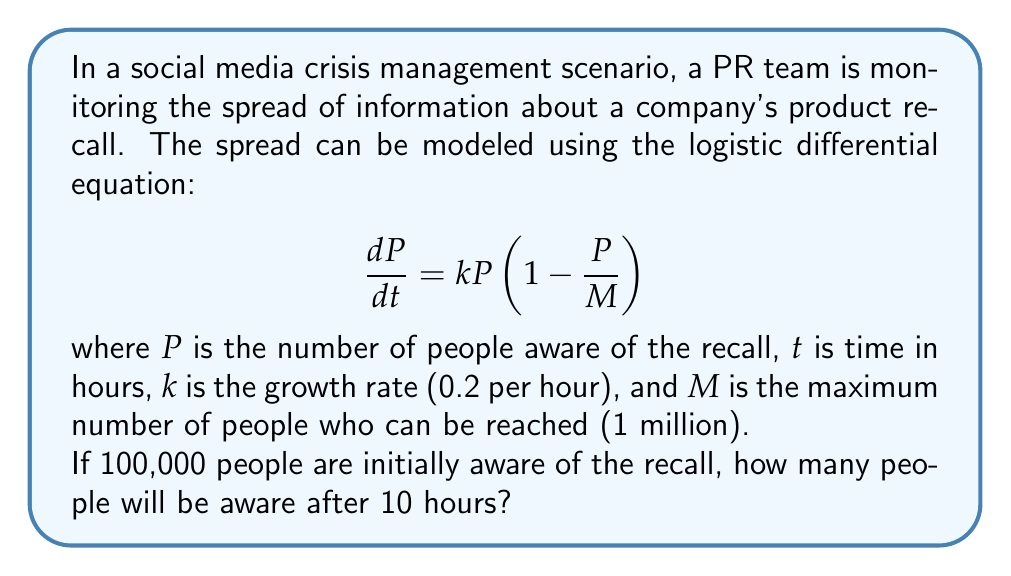Solve this math problem. To solve this problem, we need to use the solution to the logistic differential equation:

$$P(t) = \frac{M}{1 + (\frac{M}{P_0} - 1)e^{-kt}}$$

Where:
- $M = 1,000,000$ (maximum reach)
- $k = 0.2$ (growth rate per hour)
- $P_0 = 100,000$ (initial awareness)
- $t = 10$ (hours)

Let's substitute these values into the equation:

$$P(10) = \frac{1,000,000}{1 + (\frac{1,000,000}{100,000} - 1)e^{-0.2 \cdot 10}}$$

$$= \frac{1,000,000}{1 + (10 - 1)e^{-2}}$$

$$= \frac{1,000,000}{1 + 9e^{-2}}$$

Now, let's calculate:

1. $e^{-2} \approx 0.1353$
2. $9 \cdot 0.1353 = 1.2177$
3. $1 + 1.2177 = 2.2177$

Therefore:

$$P(10) = \frac{1,000,000}{2.2177} \approx 450,915$$

Rounding to the nearest whole number, as we're dealing with people.
Answer: 450,915 people 